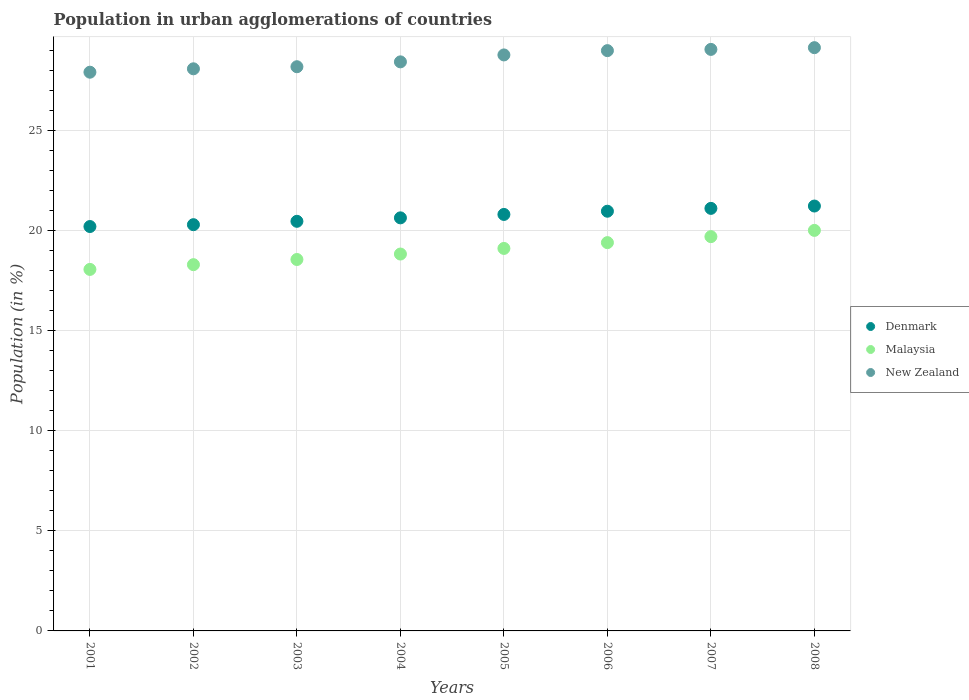Is the number of dotlines equal to the number of legend labels?
Offer a terse response. Yes. What is the percentage of population in urban agglomerations in New Zealand in 2008?
Your response must be concise. 29.12. Across all years, what is the maximum percentage of population in urban agglomerations in Malaysia?
Ensure brevity in your answer.  20. Across all years, what is the minimum percentage of population in urban agglomerations in New Zealand?
Provide a short and direct response. 27.9. In which year was the percentage of population in urban agglomerations in Malaysia minimum?
Make the answer very short. 2001. What is the total percentage of population in urban agglomerations in Denmark in the graph?
Ensure brevity in your answer.  165.62. What is the difference between the percentage of population in urban agglomerations in Malaysia in 2001 and that in 2004?
Give a very brief answer. -0.77. What is the difference between the percentage of population in urban agglomerations in Malaysia in 2002 and the percentage of population in urban agglomerations in New Zealand in 2005?
Ensure brevity in your answer.  -10.47. What is the average percentage of population in urban agglomerations in Malaysia per year?
Your answer should be compact. 18.98. In the year 2005, what is the difference between the percentage of population in urban agglomerations in Denmark and percentage of population in urban agglomerations in New Zealand?
Give a very brief answer. -7.96. What is the ratio of the percentage of population in urban agglomerations in New Zealand in 2001 to that in 2004?
Ensure brevity in your answer.  0.98. What is the difference between the highest and the second highest percentage of population in urban agglomerations in Malaysia?
Provide a succinct answer. 0.31. What is the difference between the highest and the lowest percentage of population in urban agglomerations in Denmark?
Ensure brevity in your answer.  1.02. Is the sum of the percentage of population in urban agglomerations in Denmark in 2004 and 2006 greater than the maximum percentage of population in urban agglomerations in New Zealand across all years?
Ensure brevity in your answer.  Yes. How many dotlines are there?
Your answer should be very brief. 3. What is the difference between two consecutive major ticks on the Y-axis?
Your response must be concise. 5. How many legend labels are there?
Your answer should be very brief. 3. How are the legend labels stacked?
Provide a succinct answer. Vertical. What is the title of the graph?
Keep it short and to the point. Population in urban agglomerations of countries. Does "European Union" appear as one of the legend labels in the graph?
Offer a terse response. No. What is the label or title of the X-axis?
Your answer should be very brief. Years. What is the label or title of the Y-axis?
Your answer should be compact. Population (in %). What is the Population (in %) of Denmark in 2001?
Provide a short and direct response. 20.19. What is the Population (in %) in Malaysia in 2001?
Offer a very short reply. 18.05. What is the Population (in %) of New Zealand in 2001?
Provide a short and direct response. 27.9. What is the Population (in %) of Denmark in 2002?
Provide a short and direct response. 20.28. What is the Population (in %) of Malaysia in 2002?
Your response must be concise. 18.29. What is the Population (in %) of New Zealand in 2002?
Your answer should be very brief. 28.07. What is the Population (in %) in Denmark in 2003?
Your response must be concise. 20.45. What is the Population (in %) of Malaysia in 2003?
Give a very brief answer. 18.55. What is the Population (in %) of New Zealand in 2003?
Your answer should be compact. 28.17. What is the Population (in %) of Denmark in 2004?
Provide a succinct answer. 20.63. What is the Population (in %) of Malaysia in 2004?
Provide a succinct answer. 18.82. What is the Population (in %) of New Zealand in 2004?
Your answer should be very brief. 28.41. What is the Population (in %) of Denmark in 2005?
Offer a very short reply. 20.8. What is the Population (in %) in Malaysia in 2005?
Ensure brevity in your answer.  19.1. What is the Population (in %) in New Zealand in 2005?
Your response must be concise. 28.76. What is the Population (in %) in Denmark in 2006?
Your response must be concise. 20.96. What is the Population (in %) of Malaysia in 2006?
Offer a terse response. 19.39. What is the Population (in %) in New Zealand in 2006?
Your response must be concise. 28.98. What is the Population (in %) of Denmark in 2007?
Provide a succinct answer. 21.1. What is the Population (in %) in Malaysia in 2007?
Provide a succinct answer. 19.69. What is the Population (in %) of New Zealand in 2007?
Make the answer very short. 29.04. What is the Population (in %) in Denmark in 2008?
Your answer should be very brief. 21.22. What is the Population (in %) in Malaysia in 2008?
Your response must be concise. 20. What is the Population (in %) in New Zealand in 2008?
Provide a succinct answer. 29.12. Across all years, what is the maximum Population (in %) of Denmark?
Offer a very short reply. 21.22. Across all years, what is the maximum Population (in %) in Malaysia?
Keep it short and to the point. 20. Across all years, what is the maximum Population (in %) of New Zealand?
Provide a short and direct response. 29.12. Across all years, what is the minimum Population (in %) in Denmark?
Your answer should be very brief. 20.19. Across all years, what is the minimum Population (in %) of Malaysia?
Your answer should be very brief. 18.05. Across all years, what is the minimum Population (in %) of New Zealand?
Keep it short and to the point. 27.9. What is the total Population (in %) of Denmark in the graph?
Make the answer very short. 165.62. What is the total Population (in %) in Malaysia in the graph?
Your answer should be compact. 151.88. What is the total Population (in %) in New Zealand in the graph?
Offer a terse response. 228.45. What is the difference between the Population (in %) in Denmark in 2001 and that in 2002?
Your answer should be very brief. -0.09. What is the difference between the Population (in %) in Malaysia in 2001 and that in 2002?
Ensure brevity in your answer.  -0.24. What is the difference between the Population (in %) of New Zealand in 2001 and that in 2002?
Provide a short and direct response. -0.17. What is the difference between the Population (in %) in Denmark in 2001 and that in 2003?
Ensure brevity in your answer.  -0.26. What is the difference between the Population (in %) of Malaysia in 2001 and that in 2003?
Provide a short and direct response. -0.5. What is the difference between the Population (in %) in New Zealand in 2001 and that in 2003?
Give a very brief answer. -0.27. What is the difference between the Population (in %) in Denmark in 2001 and that in 2004?
Keep it short and to the point. -0.43. What is the difference between the Population (in %) of Malaysia in 2001 and that in 2004?
Offer a very short reply. -0.77. What is the difference between the Population (in %) in New Zealand in 2001 and that in 2004?
Your answer should be compact. -0.52. What is the difference between the Population (in %) in Denmark in 2001 and that in 2005?
Give a very brief answer. -0.6. What is the difference between the Population (in %) of Malaysia in 2001 and that in 2005?
Your answer should be compact. -1.05. What is the difference between the Population (in %) in New Zealand in 2001 and that in 2005?
Give a very brief answer. -0.86. What is the difference between the Population (in %) of Denmark in 2001 and that in 2006?
Make the answer very short. -0.76. What is the difference between the Population (in %) of Malaysia in 2001 and that in 2006?
Ensure brevity in your answer.  -1.34. What is the difference between the Population (in %) in New Zealand in 2001 and that in 2006?
Provide a short and direct response. -1.08. What is the difference between the Population (in %) of Denmark in 2001 and that in 2007?
Offer a very short reply. -0.91. What is the difference between the Population (in %) in Malaysia in 2001 and that in 2007?
Keep it short and to the point. -1.64. What is the difference between the Population (in %) in New Zealand in 2001 and that in 2007?
Give a very brief answer. -1.14. What is the difference between the Population (in %) in Denmark in 2001 and that in 2008?
Offer a very short reply. -1.02. What is the difference between the Population (in %) in Malaysia in 2001 and that in 2008?
Provide a short and direct response. -1.95. What is the difference between the Population (in %) of New Zealand in 2001 and that in 2008?
Your response must be concise. -1.23. What is the difference between the Population (in %) in Denmark in 2002 and that in 2003?
Make the answer very short. -0.17. What is the difference between the Population (in %) in Malaysia in 2002 and that in 2003?
Your answer should be very brief. -0.26. What is the difference between the Population (in %) of New Zealand in 2002 and that in 2003?
Give a very brief answer. -0.1. What is the difference between the Population (in %) of Denmark in 2002 and that in 2004?
Your answer should be very brief. -0.34. What is the difference between the Population (in %) of Malaysia in 2002 and that in 2004?
Your answer should be compact. -0.53. What is the difference between the Population (in %) in New Zealand in 2002 and that in 2004?
Your response must be concise. -0.35. What is the difference between the Population (in %) of Denmark in 2002 and that in 2005?
Keep it short and to the point. -0.51. What is the difference between the Population (in %) in Malaysia in 2002 and that in 2005?
Make the answer very short. -0.81. What is the difference between the Population (in %) of New Zealand in 2002 and that in 2005?
Give a very brief answer. -0.69. What is the difference between the Population (in %) in Denmark in 2002 and that in 2006?
Keep it short and to the point. -0.67. What is the difference between the Population (in %) of Malaysia in 2002 and that in 2006?
Your response must be concise. -1.1. What is the difference between the Population (in %) in New Zealand in 2002 and that in 2006?
Your answer should be very brief. -0.91. What is the difference between the Population (in %) of Denmark in 2002 and that in 2007?
Provide a succinct answer. -0.81. What is the difference between the Population (in %) of Malaysia in 2002 and that in 2007?
Your response must be concise. -1.4. What is the difference between the Population (in %) of New Zealand in 2002 and that in 2007?
Offer a terse response. -0.97. What is the difference between the Population (in %) of Denmark in 2002 and that in 2008?
Provide a succinct answer. -0.93. What is the difference between the Population (in %) of Malaysia in 2002 and that in 2008?
Offer a very short reply. -1.71. What is the difference between the Population (in %) of New Zealand in 2002 and that in 2008?
Give a very brief answer. -1.06. What is the difference between the Population (in %) in Denmark in 2003 and that in 2004?
Ensure brevity in your answer.  -0.17. What is the difference between the Population (in %) of Malaysia in 2003 and that in 2004?
Keep it short and to the point. -0.27. What is the difference between the Population (in %) of New Zealand in 2003 and that in 2004?
Ensure brevity in your answer.  -0.24. What is the difference between the Population (in %) in Denmark in 2003 and that in 2005?
Offer a very short reply. -0.34. What is the difference between the Population (in %) of Malaysia in 2003 and that in 2005?
Offer a terse response. -0.55. What is the difference between the Population (in %) of New Zealand in 2003 and that in 2005?
Offer a very short reply. -0.59. What is the difference between the Population (in %) of Denmark in 2003 and that in 2006?
Your response must be concise. -0.5. What is the difference between the Population (in %) of Malaysia in 2003 and that in 2006?
Ensure brevity in your answer.  -0.84. What is the difference between the Population (in %) of New Zealand in 2003 and that in 2006?
Provide a short and direct response. -0.8. What is the difference between the Population (in %) in Denmark in 2003 and that in 2007?
Offer a very short reply. -0.65. What is the difference between the Population (in %) of Malaysia in 2003 and that in 2007?
Ensure brevity in your answer.  -1.14. What is the difference between the Population (in %) of New Zealand in 2003 and that in 2007?
Keep it short and to the point. -0.87. What is the difference between the Population (in %) in Denmark in 2003 and that in 2008?
Make the answer very short. -0.76. What is the difference between the Population (in %) in Malaysia in 2003 and that in 2008?
Give a very brief answer. -1.45. What is the difference between the Population (in %) of New Zealand in 2003 and that in 2008?
Provide a short and direct response. -0.95. What is the difference between the Population (in %) of Denmark in 2004 and that in 2005?
Provide a short and direct response. -0.17. What is the difference between the Population (in %) of Malaysia in 2004 and that in 2005?
Offer a very short reply. -0.28. What is the difference between the Population (in %) in New Zealand in 2004 and that in 2005?
Your answer should be very brief. -0.35. What is the difference between the Population (in %) in Denmark in 2004 and that in 2006?
Offer a terse response. -0.33. What is the difference between the Population (in %) of Malaysia in 2004 and that in 2006?
Keep it short and to the point. -0.57. What is the difference between the Population (in %) in New Zealand in 2004 and that in 2006?
Ensure brevity in your answer.  -0.56. What is the difference between the Population (in %) in Denmark in 2004 and that in 2007?
Keep it short and to the point. -0.47. What is the difference between the Population (in %) of Malaysia in 2004 and that in 2007?
Give a very brief answer. -0.87. What is the difference between the Population (in %) in New Zealand in 2004 and that in 2007?
Your response must be concise. -0.62. What is the difference between the Population (in %) of Denmark in 2004 and that in 2008?
Offer a very short reply. -0.59. What is the difference between the Population (in %) in Malaysia in 2004 and that in 2008?
Provide a short and direct response. -1.18. What is the difference between the Population (in %) in New Zealand in 2004 and that in 2008?
Your response must be concise. -0.71. What is the difference between the Population (in %) of Denmark in 2005 and that in 2006?
Offer a terse response. -0.16. What is the difference between the Population (in %) in Malaysia in 2005 and that in 2006?
Your response must be concise. -0.29. What is the difference between the Population (in %) in New Zealand in 2005 and that in 2006?
Offer a terse response. -0.21. What is the difference between the Population (in %) of Denmark in 2005 and that in 2007?
Provide a short and direct response. -0.3. What is the difference between the Population (in %) in Malaysia in 2005 and that in 2007?
Keep it short and to the point. -0.59. What is the difference between the Population (in %) in New Zealand in 2005 and that in 2007?
Provide a short and direct response. -0.28. What is the difference between the Population (in %) of Denmark in 2005 and that in 2008?
Make the answer very short. -0.42. What is the difference between the Population (in %) in Malaysia in 2005 and that in 2008?
Your answer should be compact. -0.9. What is the difference between the Population (in %) of New Zealand in 2005 and that in 2008?
Your response must be concise. -0.36. What is the difference between the Population (in %) in Denmark in 2006 and that in 2007?
Your answer should be very brief. -0.14. What is the difference between the Population (in %) of Malaysia in 2006 and that in 2007?
Offer a very short reply. -0.3. What is the difference between the Population (in %) in New Zealand in 2006 and that in 2007?
Your answer should be compact. -0.06. What is the difference between the Population (in %) of Denmark in 2006 and that in 2008?
Give a very brief answer. -0.26. What is the difference between the Population (in %) in Malaysia in 2006 and that in 2008?
Your answer should be very brief. -0.61. What is the difference between the Population (in %) of New Zealand in 2006 and that in 2008?
Provide a short and direct response. -0.15. What is the difference between the Population (in %) of Denmark in 2007 and that in 2008?
Provide a short and direct response. -0.12. What is the difference between the Population (in %) in Malaysia in 2007 and that in 2008?
Keep it short and to the point. -0.31. What is the difference between the Population (in %) in New Zealand in 2007 and that in 2008?
Provide a succinct answer. -0.09. What is the difference between the Population (in %) in Denmark in 2001 and the Population (in %) in Malaysia in 2002?
Your answer should be compact. 1.9. What is the difference between the Population (in %) in Denmark in 2001 and the Population (in %) in New Zealand in 2002?
Provide a short and direct response. -7.88. What is the difference between the Population (in %) in Malaysia in 2001 and the Population (in %) in New Zealand in 2002?
Ensure brevity in your answer.  -10.02. What is the difference between the Population (in %) in Denmark in 2001 and the Population (in %) in Malaysia in 2003?
Make the answer very short. 1.65. What is the difference between the Population (in %) in Denmark in 2001 and the Population (in %) in New Zealand in 2003?
Make the answer very short. -7.98. What is the difference between the Population (in %) in Malaysia in 2001 and the Population (in %) in New Zealand in 2003?
Make the answer very short. -10.12. What is the difference between the Population (in %) in Denmark in 2001 and the Population (in %) in Malaysia in 2004?
Make the answer very short. 1.37. What is the difference between the Population (in %) of Denmark in 2001 and the Population (in %) of New Zealand in 2004?
Give a very brief answer. -8.22. What is the difference between the Population (in %) in Malaysia in 2001 and the Population (in %) in New Zealand in 2004?
Make the answer very short. -10.36. What is the difference between the Population (in %) in Denmark in 2001 and the Population (in %) in Malaysia in 2005?
Your answer should be compact. 1.09. What is the difference between the Population (in %) in Denmark in 2001 and the Population (in %) in New Zealand in 2005?
Keep it short and to the point. -8.57. What is the difference between the Population (in %) in Malaysia in 2001 and the Population (in %) in New Zealand in 2005?
Your answer should be very brief. -10.71. What is the difference between the Population (in %) in Denmark in 2001 and the Population (in %) in Malaysia in 2006?
Offer a terse response. 0.8. What is the difference between the Population (in %) of Denmark in 2001 and the Population (in %) of New Zealand in 2006?
Give a very brief answer. -8.78. What is the difference between the Population (in %) in Malaysia in 2001 and the Population (in %) in New Zealand in 2006?
Ensure brevity in your answer.  -10.92. What is the difference between the Population (in %) in Denmark in 2001 and the Population (in %) in Malaysia in 2007?
Provide a succinct answer. 0.5. What is the difference between the Population (in %) in Denmark in 2001 and the Population (in %) in New Zealand in 2007?
Offer a terse response. -8.84. What is the difference between the Population (in %) of Malaysia in 2001 and the Population (in %) of New Zealand in 2007?
Your response must be concise. -10.99. What is the difference between the Population (in %) of Denmark in 2001 and the Population (in %) of Malaysia in 2008?
Ensure brevity in your answer.  0.19. What is the difference between the Population (in %) of Denmark in 2001 and the Population (in %) of New Zealand in 2008?
Your answer should be very brief. -8.93. What is the difference between the Population (in %) in Malaysia in 2001 and the Population (in %) in New Zealand in 2008?
Your response must be concise. -11.07. What is the difference between the Population (in %) of Denmark in 2002 and the Population (in %) of Malaysia in 2003?
Your answer should be very brief. 1.74. What is the difference between the Population (in %) of Denmark in 2002 and the Population (in %) of New Zealand in 2003?
Your answer should be compact. -7.89. What is the difference between the Population (in %) of Malaysia in 2002 and the Population (in %) of New Zealand in 2003?
Keep it short and to the point. -9.88. What is the difference between the Population (in %) of Denmark in 2002 and the Population (in %) of Malaysia in 2004?
Provide a short and direct response. 1.47. What is the difference between the Population (in %) of Denmark in 2002 and the Population (in %) of New Zealand in 2004?
Give a very brief answer. -8.13. What is the difference between the Population (in %) in Malaysia in 2002 and the Population (in %) in New Zealand in 2004?
Ensure brevity in your answer.  -10.13. What is the difference between the Population (in %) of Denmark in 2002 and the Population (in %) of Malaysia in 2005?
Your answer should be compact. 1.19. What is the difference between the Population (in %) of Denmark in 2002 and the Population (in %) of New Zealand in 2005?
Offer a terse response. -8.48. What is the difference between the Population (in %) of Malaysia in 2002 and the Population (in %) of New Zealand in 2005?
Give a very brief answer. -10.47. What is the difference between the Population (in %) in Denmark in 2002 and the Population (in %) in Malaysia in 2006?
Your answer should be very brief. 0.9. What is the difference between the Population (in %) in Denmark in 2002 and the Population (in %) in New Zealand in 2006?
Your answer should be very brief. -8.69. What is the difference between the Population (in %) in Malaysia in 2002 and the Population (in %) in New Zealand in 2006?
Keep it short and to the point. -10.69. What is the difference between the Population (in %) in Denmark in 2002 and the Population (in %) in Malaysia in 2007?
Make the answer very short. 0.6. What is the difference between the Population (in %) of Denmark in 2002 and the Population (in %) of New Zealand in 2007?
Offer a terse response. -8.75. What is the difference between the Population (in %) in Malaysia in 2002 and the Population (in %) in New Zealand in 2007?
Offer a very short reply. -10.75. What is the difference between the Population (in %) of Denmark in 2002 and the Population (in %) of Malaysia in 2008?
Your answer should be very brief. 0.28. What is the difference between the Population (in %) of Denmark in 2002 and the Population (in %) of New Zealand in 2008?
Your answer should be compact. -8.84. What is the difference between the Population (in %) in Malaysia in 2002 and the Population (in %) in New Zealand in 2008?
Provide a succinct answer. -10.84. What is the difference between the Population (in %) in Denmark in 2003 and the Population (in %) in Malaysia in 2004?
Your answer should be compact. 1.63. What is the difference between the Population (in %) of Denmark in 2003 and the Population (in %) of New Zealand in 2004?
Ensure brevity in your answer.  -7.96. What is the difference between the Population (in %) in Malaysia in 2003 and the Population (in %) in New Zealand in 2004?
Offer a very short reply. -9.87. What is the difference between the Population (in %) in Denmark in 2003 and the Population (in %) in Malaysia in 2005?
Your answer should be compact. 1.35. What is the difference between the Population (in %) of Denmark in 2003 and the Population (in %) of New Zealand in 2005?
Ensure brevity in your answer.  -8.31. What is the difference between the Population (in %) in Malaysia in 2003 and the Population (in %) in New Zealand in 2005?
Provide a short and direct response. -10.21. What is the difference between the Population (in %) of Denmark in 2003 and the Population (in %) of Malaysia in 2006?
Ensure brevity in your answer.  1.06. What is the difference between the Population (in %) of Denmark in 2003 and the Population (in %) of New Zealand in 2006?
Your response must be concise. -8.52. What is the difference between the Population (in %) in Malaysia in 2003 and the Population (in %) in New Zealand in 2006?
Give a very brief answer. -10.43. What is the difference between the Population (in %) of Denmark in 2003 and the Population (in %) of Malaysia in 2007?
Offer a very short reply. 0.77. What is the difference between the Population (in %) of Denmark in 2003 and the Population (in %) of New Zealand in 2007?
Your answer should be compact. -8.58. What is the difference between the Population (in %) in Malaysia in 2003 and the Population (in %) in New Zealand in 2007?
Provide a succinct answer. -10.49. What is the difference between the Population (in %) in Denmark in 2003 and the Population (in %) in Malaysia in 2008?
Your answer should be compact. 0.45. What is the difference between the Population (in %) in Denmark in 2003 and the Population (in %) in New Zealand in 2008?
Provide a succinct answer. -8.67. What is the difference between the Population (in %) of Malaysia in 2003 and the Population (in %) of New Zealand in 2008?
Your response must be concise. -10.58. What is the difference between the Population (in %) in Denmark in 2004 and the Population (in %) in Malaysia in 2005?
Your response must be concise. 1.53. What is the difference between the Population (in %) of Denmark in 2004 and the Population (in %) of New Zealand in 2005?
Your response must be concise. -8.13. What is the difference between the Population (in %) in Malaysia in 2004 and the Population (in %) in New Zealand in 2005?
Ensure brevity in your answer.  -9.94. What is the difference between the Population (in %) in Denmark in 2004 and the Population (in %) in Malaysia in 2006?
Provide a succinct answer. 1.24. What is the difference between the Population (in %) of Denmark in 2004 and the Population (in %) of New Zealand in 2006?
Ensure brevity in your answer.  -8.35. What is the difference between the Population (in %) of Malaysia in 2004 and the Population (in %) of New Zealand in 2006?
Your answer should be compact. -10.16. What is the difference between the Population (in %) of Denmark in 2004 and the Population (in %) of Malaysia in 2007?
Offer a very short reply. 0.94. What is the difference between the Population (in %) of Denmark in 2004 and the Population (in %) of New Zealand in 2007?
Keep it short and to the point. -8.41. What is the difference between the Population (in %) of Malaysia in 2004 and the Population (in %) of New Zealand in 2007?
Make the answer very short. -10.22. What is the difference between the Population (in %) in Denmark in 2004 and the Population (in %) in Malaysia in 2008?
Your answer should be compact. 0.63. What is the difference between the Population (in %) in Denmark in 2004 and the Population (in %) in New Zealand in 2008?
Your answer should be very brief. -8.5. What is the difference between the Population (in %) in Malaysia in 2004 and the Population (in %) in New Zealand in 2008?
Offer a very short reply. -10.3. What is the difference between the Population (in %) of Denmark in 2005 and the Population (in %) of Malaysia in 2006?
Your answer should be compact. 1.41. What is the difference between the Population (in %) of Denmark in 2005 and the Population (in %) of New Zealand in 2006?
Keep it short and to the point. -8.18. What is the difference between the Population (in %) in Malaysia in 2005 and the Population (in %) in New Zealand in 2006?
Offer a very short reply. -9.88. What is the difference between the Population (in %) in Denmark in 2005 and the Population (in %) in Malaysia in 2007?
Your answer should be compact. 1.11. What is the difference between the Population (in %) of Denmark in 2005 and the Population (in %) of New Zealand in 2007?
Provide a short and direct response. -8.24. What is the difference between the Population (in %) of Malaysia in 2005 and the Population (in %) of New Zealand in 2007?
Ensure brevity in your answer.  -9.94. What is the difference between the Population (in %) of Denmark in 2005 and the Population (in %) of Malaysia in 2008?
Keep it short and to the point. 0.8. What is the difference between the Population (in %) in Denmark in 2005 and the Population (in %) in New Zealand in 2008?
Ensure brevity in your answer.  -8.33. What is the difference between the Population (in %) of Malaysia in 2005 and the Population (in %) of New Zealand in 2008?
Offer a very short reply. -10.02. What is the difference between the Population (in %) in Denmark in 2006 and the Population (in %) in Malaysia in 2007?
Offer a very short reply. 1.27. What is the difference between the Population (in %) in Denmark in 2006 and the Population (in %) in New Zealand in 2007?
Make the answer very short. -8.08. What is the difference between the Population (in %) of Malaysia in 2006 and the Population (in %) of New Zealand in 2007?
Make the answer very short. -9.65. What is the difference between the Population (in %) in Denmark in 2006 and the Population (in %) in Malaysia in 2008?
Provide a short and direct response. 0.96. What is the difference between the Population (in %) of Denmark in 2006 and the Population (in %) of New Zealand in 2008?
Provide a short and direct response. -8.17. What is the difference between the Population (in %) of Malaysia in 2006 and the Population (in %) of New Zealand in 2008?
Provide a short and direct response. -9.74. What is the difference between the Population (in %) in Denmark in 2007 and the Population (in %) in Malaysia in 2008?
Keep it short and to the point. 1.1. What is the difference between the Population (in %) in Denmark in 2007 and the Population (in %) in New Zealand in 2008?
Provide a succinct answer. -8.02. What is the difference between the Population (in %) of Malaysia in 2007 and the Population (in %) of New Zealand in 2008?
Keep it short and to the point. -9.44. What is the average Population (in %) in Denmark per year?
Offer a terse response. 20.7. What is the average Population (in %) of Malaysia per year?
Give a very brief answer. 18.98. What is the average Population (in %) in New Zealand per year?
Provide a succinct answer. 28.56. In the year 2001, what is the difference between the Population (in %) of Denmark and Population (in %) of Malaysia?
Ensure brevity in your answer.  2.14. In the year 2001, what is the difference between the Population (in %) in Denmark and Population (in %) in New Zealand?
Make the answer very short. -7.71. In the year 2001, what is the difference between the Population (in %) of Malaysia and Population (in %) of New Zealand?
Ensure brevity in your answer.  -9.85. In the year 2002, what is the difference between the Population (in %) of Denmark and Population (in %) of Malaysia?
Give a very brief answer. 2. In the year 2002, what is the difference between the Population (in %) in Denmark and Population (in %) in New Zealand?
Give a very brief answer. -7.78. In the year 2002, what is the difference between the Population (in %) in Malaysia and Population (in %) in New Zealand?
Provide a short and direct response. -9.78. In the year 2003, what is the difference between the Population (in %) of Denmark and Population (in %) of Malaysia?
Provide a succinct answer. 1.91. In the year 2003, what is the difference between the Population (in %) of Denmark and Population (in %) of New Zealand?
Keep it short and to the point. -7.72. In the year 2003, what is the difference between the Population (in %) in Malaysia and Population (in %) in New Zealand?
Keep it short and to the point. -9.63. In the year 2004, what is the difference between the Population (in %) in Denmark and Population (in %) in Malaysia?
Make the answer very short. 1.81. In the year 2004, what is the difference between the Population (in %) in Denmark and Population (in %) in New Zealand?
Keep it short and to the point. -7.79. In the year 2004, what is the difference between the Population (in %) in Malaysia and Population (in %) in New Zealand?
Your answer should be compact. -9.6. In the year 2005, what is the difference between the Population (in %) of Denmark and Population (in %) of Malaysia?
Your answer should be very brief. 1.7. In the year 2005, what is the difference between the Population (in %) in Denmark and Population (in %) in New Zealand?
Provide a succinct answer. -7.96. In the year 2005, what is the difference between the Population (in %) in Malaysia and Population (in %) in New Zealand?
Offer a very short reply. -9.66. In the year 2006, what is the difference between the Population (in %) of Denmark and Population (in %) of Malaysia?
Your answer should be compact. 1.57. In the year 2006, what is the difference between the Population (in %) of Denmark and Population (in %) of New Zealand?
Keep it short and to the point. -8.02. In the year 2006, what is the difference between the Population (in %) in Malaysia and Population (in %) in New Zealand?
Offer a terse response. -9.59. In the year 2007, what is the difference between the Population (in %) in Denmark and Population (in %) in Malaysia?
Your response must be concise. 1.41. In the year 2007, what is the difference between the Population (in %) of Denmark and Population (in %) of New Zealand?
Keep it short and to the point. -7.94. In the year 2007, what is the difference between the Population (in %) of Malaysia and Population (in %) of New Zealand?
Provide a succinct answer. -9.35. In the year 2008, what is the difference between the Population (in %) of Denmark and Population (in %) of Malaysia?
Provide a short and direct response. 1.22. In the year 2008, what is the difference between the Population (in %) in Denmark and Population (in %) in New Zealand?
Your answer should be very brief. -7.91. In the year 2008, what is the difference between the Population (in %) of Malaysia and Population (in %) of New Zealand?
Provide a short and direct response. -9.12. What is the ratio of the Population (in %) in Denmark in 2001 to that in 2002?
Your response must be concise. 1. What is the ratio of the Population (in %) in Malaysia in 2001 to that in 2002?
Your answer should be very brief. 0.99. What is the ratio of the Population (in %) of Denmark in 2001 to that in 2003?
Your answer should be very brief. 0.99. What is the ratio of the Population (in %) of Malaysia in 2001 to that in 2003?
Offer a very short reply. 0.97. What is the ratio of the Population (in %) of New Zealand in 2001 to that in 2003?
Give a very brief answer. 0.99. What is the ratio of the Population (in %) in Denmark in 2001 to that in 2004?
Provide a succinct answer. 0.98. What is the ratio of the Population (in %) of Malaysia in 2001 to that in 2004?
Your answer should be compact. 0.96. What is the ratio of the Population (in %) of New Zealand in 2001 to that in 2004?
Offer a very short reply. 0.98. What is the ratio of the Population (in %) in Denmark in 2001 to that in 2005?
Ensure brevity in your answer.  0.97. What is the ratio of the Population (in %) of Malaysia in 2001 to that in 2005?
Provide a succinct answer. 0.95. What is the ratio of the Population (in %) of New Zealand in 2001 to that in 2005?
Your answer should be compact. 0.97. What is the ratio of the Population (in %) in Denmark in 2001 to that in 2006?
Make the answer very short. 0.96. What is the ratio of the Population (in %) of New Zealand in 2001 to that in 2006?
Give a very brief answer. 0.96. What is the ratio of the Population (in %) in Denmark in 2001 to that in 2007?
Your answer should be very brief. 0.96. What is the ratio of the Population (in %) in Malaysia in 2001 to that in 2007?
Ensure brevity in your answer.  0.92. What is the ratio of the Population (in %) of New Zealand in 2001 to that in 2007?
Ensure brevity in your answer.  0.96. What is the ratio of the Population (in %) of Denmark in 2001 to that in 2008?
Offer a terse response. 0.95. What is the ratio of the Population (in %) of Malaysia in 2001 to that in 2008?
Offer a very short reply. 0.9. What is the ratio of the Population (in %) in New Zealand in 2001 to that in 2008?
Offer a very short reply. 0.96. What is the ratio of the Population (in %) in Denmark in 2002 to that in 2003?
Keep it short and to the point. 0.99. What is the ratio of the Population (in %) of Malaysia in 2002 to that in 2003?
Provide a succinct answer. 0.99. What is the ratio of the Population (in %) in New Zealand in 2002 to that in 2003?
Your answer should be compact. 1. What is the ratio of the Population (in %) of Denmark in 2002 to that in 2004?
Provide a succinct answer. 0.98. What is the ratio of the Population (in %) in Malaysia in 2002 to that in 2004?
Your answer should be very brief. 0.97. What is the ratio of the Population (in %) in New Zealand in 2002 to that in 2004?
Your answer should be very brief. 0.99. What is the ratio of the Population (in %) of Denmark in 2002 to that in 2005?
Provide a succinct answer. 0.98. What is the ratio of the Population (in %) of Malaysia in 2002 to that in 2005?
Offer a terse response. 0.96. What is the ratio of the Population (in %) of New Zealand in 2002 to that in 2005?
Offer a very short reply. 0.98. What is the ratio of the Population (in %) of Denmark in 2002 to that in 2006?
Offer a terse response. 0.97. What is the ratio of the Population (in %) in Malaysia in 2002 to that in 2006?
Offer a very short reply. 0.94. What is the ratio of the Population (in %) of New Zealand in 2002 to that in 2006?
Offer a very short reply. 0.97. What is the ratio of the Population (in %) in Denmark in 2002 to that in 2007?
Make the answer very short. 0.96. What is the ratio of the Population (in %) in Malaysia in 2002 to that in 2007?
Offer a terse response. 0.93. What is the ratio of the Population (in %) in New Zealand in 2002 to that in 2007?
Ensure brevity in your answer.  0.97. What is the ratio of the Population (in %) of Denmark in 2002 to that in 2008?
Offer a terse response. 0.96. What is the ratio of the Population (in %) in Malaysia in 2002 to that in 2008?
Your response must be concise. 0.91. What is the ratio of the Population (in %) in New Zealand in 2002 to that in 2008?
Offer a very short reply. 0.96. What is the ratio of the Population (in %) of Denmark in 2003 to that in 2004?
Make the answer very short. 0.99. What is the ratio of the Population (in %) in Malaysia in 2003 to that in 2004?
Your response must be concise. 0.99. What is the ratio of the Population (in %) in Denmark in 2003 to that in 2005?
Make the answer very short. 0.98. What is the ratio of the Population (in %) of Malaysia in 2003 to that in 2005?
Your answer should be very brief. 0.97. What is the ratio of the Population (in %) of New Zealand in 2003 to that in 2005?
Offer a very short reply. 0.98. What is the ratio of the Population (in %) of Malaysia in 2003 to that in 2006?
Your answer should be compact. 0.96. What is the ratio of the Population (in %) of New Zealand in 2003 to that in 2006?
Offer a terse response. 0.97. What is the ratio of the Population (in %) in Denmark in 2003 to that in 2007?
Ensure brevity in your answer.  0.97. What is the ratio of the Population (in %) in Malaysia in 2003 to that in 2007?
Provide a short and direct response. 0.94. What is the ratio of the Population (in %) of New Zealand in 2003 to that in 2007?
Your answer should be very brief. 0.97. What is the ratio of the Population (in %) of Denmark in 2003 to that in 2008?
Make the answer very short. 0.96. What is the ratio of the Population (in %) in Malaysia in 2003 to that in 2008?
Make the answer very short. 0.93. What is the ratio of the Population (in %) in New Zealand in 2003 to that in 2008?
Give a very brief answer. 0.97. What is the ratio of the Population (in %) in Malaysia in 2004 to that in 2005?
Your response must be concise. 0.99. What is the ratio of the Population (in %) in New Zealand in 2004 to that in 2005?
Offer a very short reply. 0.99. What is the ratio of the Population (in %) of Denmark in 2004 to that in 2006?
Make the answer very short. 0.98. What is the ratio of the Population (in %) in Malaysia in 2004 to that in 2006?
Offer a terse response. 0.97. What is the ratio of the Population (in %) in New Zealand in 2004 to that in 2006?
Ensure brevity in your answer.  0.98. What is the ratio of the Population (in %) of Denmark in 2004 to that in 2007?
Your answer should be compact. 0.98. What is the ratio of the Population (in %) in Malaysia in 2004 to that in 2007?
Your response must be concise. 0.96. What is the ratio of the Population (in %) in New Zealand in 2004 to that in 2007?
Your response must be concise. 0.98. What is the ratio of the Population (in %) in Denmark in 2004 to that in 2008?
Your answer should be very brief. 0.97. What is the ratio of the Population (in %) of Malaysia in 2004 to that in 2008?
Provide a short and direct response. 0.94. What is the ratio of the Population (in %) of New Zealand in 2004 to that in 2008?
Offer a terse response. 0.98. What is the ratio of the Population (in %) in Denmark in 2005 to that in 2006?
Offer a very short reply. 0.99. What is the ratio of the Population (in %) in Malaysia in 2005 to that in 2006?
Make the answer very short. 0.99. What is the ratio of the Population (in %) in New Zealand in 2005 to that in 2006?
Ensure brevity in your answer.  0.99. What is the ratio of the Population (in %) in Denmark in 2005 to that in 2007?
Give a very brief answer. 0.99. What is the ratio of the Population (in %) in Malaysia in 2005 to that in 2007?
Make the answer very short. 0.97. What is the ratio of the Population (in %) in Denmark in 2005 to that in 2008?
Provide a succinct answer. 0.98. What is the ratio of the Population (in %) in Malaysia in 2005 to that in 2008?
Give a very brief answer. 0.95. What is the ratio of the Population (in %) in New Zealand in 2005 to that in 2008?
Offer a very short reply. 0.99. What is the ratio of the Population (in %) of Malaysia in 2006 to that in 2008?
Give a very brief answer. 0.97. What is the ratio of the Population (in %) of Denmark in 2007 to that in 2008?
Give a very brief answer. 0.99. What is the ratio of the Population (in %) in Malaysia in 2007 to that in 2008?
Give a very brief answer. 0.98. What is the ratio of the Population (in %) of New Zealand in 2007 to that in 2008?
Make the answer very short. 1. What is the difference between the highest and the second highest Population (in %) in Denmark?
Your answer should be compact. 0.12. What is the difference between the highest and the second highest Population (in %) in Malaysia?
Make the answer very short. 0.31. What is the difference between the highest and the second highest Population (in %) of New Zealand?
Your response must be concise. 0.09. What is the difference between the highest and the lowest Population (in %) of Denmark?
Provide a succinct answer. 1.02. What is the difference between the highest and the lowest Population (in %) of Malaysia?
Offer a very short reply. 1.95. What is the difference between the highest and the lowest Population (in %) in New Zealand?
Provide a short and direct response. 1.23. 